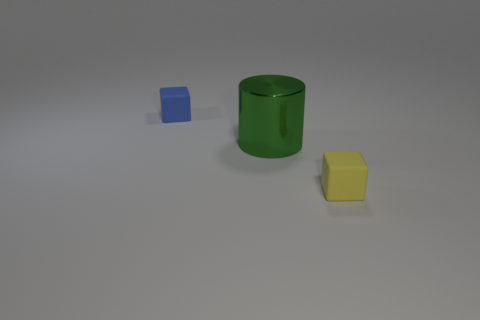Is there anything else that has the same material as the green object?
Offer a terse response. No. Does the green thing have the same shape as the blue thing?
Keep it short and to the point. No. Is there anything else that has the same size as the green metal thing?
Provide a short and direct response. No. What size is the blue rubber object that is the same shape as the yellow object?
Your answer should be compact. Small. Is the number of large green metal things that are in front of the yellow rubber object greater than the number of objects that are behind the green object?
Provide a succinct answer. No. Are the green object and the tiny object on the right side of the tiny blue object made of the same material?
Your answer should be very brief. No. Is there any other thing that has the same shape as the blue rubber object?
Offer a terse response. Yes. What is the color of the thing that is both behind the tiny yellow rubber thing and to the right of the blue matte cube?
Provide a short and direct response. Green. There is a object left of the large green shiny object; what shape is it?
Your response must be concise. Cube. What is the size of the cube that is to the left of the matte cube that is right of the small block behind the green cylinder?
Ensure brevity in your answer.  Small. 